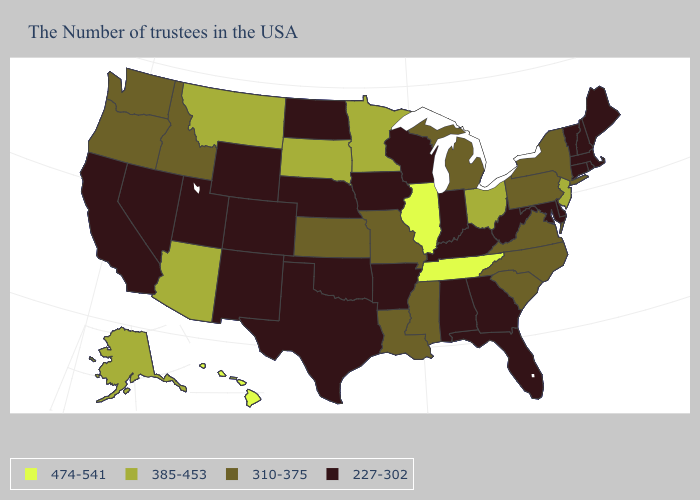Name the states that have a value in the range 310-375?
Quick response, please. New York, Pennsylvania, Virginia, North Carolina, South Carolina, Michigan, Mississippi, Louisiana, Missouri, Kansas, Idaho, Washington, Oregon. What is the highest value in the Northeast ?
Write a very short answer. 385-453. Name the states that have a value in the range 227-302?
Short answer required. Maine, Massachusetts, Rhode Island, New Hampshire, Vermont, Connecticut, Delaware, Maryland, West Virginia, Florida, Georgia, Kentucky, Indiana, Alabama, Wisconsin, Arkansas, Iowa, Nebraska, Oklahoma, Texas, North Dakota, Wyoming, Colorado, New Mexico, Utah, Nevada, California. What is the lowest value in the USA?
Write a very short answer. 227-302. Name the states that have a value in the range 385-453?
Answer briefly. New Jersey, Ohio, Minnesota, South Dakota, Montana, Arizona, Alaska. Which states hav the highest value in the West?
Concise answer only. Hawaii. Among the states that border Texas , does Oklahoma have the lowest value?
Quick response, please. Yes. What is the value of Alaska?
Write a very short answer. 385-453. What is the value of Delaware?
Concise answer only. 227-302. Among the states that border Montana , does North Dakota have the highest value?
Quick response, please. No. Does Virginia have the same value as Alabama?
Answer briefly. No. What is the value of Rhode Island?
Write a very short answer. 227-302. Name the states that have a value in the range 474-541?
Keep it brief. Tennessee, Illinois, Hawaii. Which states have the lowest value in the Northeast?
Be succinct. Maine, Massachusetts, Rhode Island, New Hampshire, Vermont, Connecticut. 